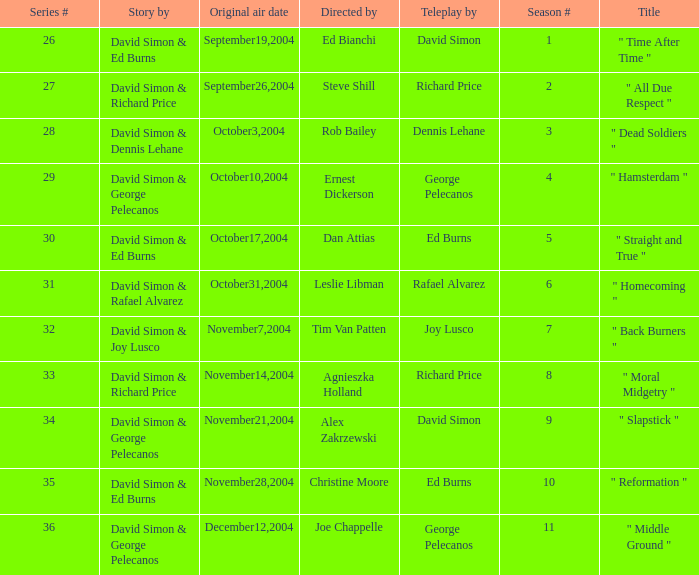Give me the full table as a dictionary. {'header': ['Series #', 'Story by', 'Original air date', 'Directed by', 'Teleplay by', 'Season #', 'Title'], 'rows': [['26', 'David Simon & Ed Burns', 'September19,2004', 'Ed Bianchi', 'David Simon', '1', '" Time After Time "'], ['27', 'David Simon & Richard Price', 'September26,2004', 'Steve Shill', 'Richard Price', '2', '" All Due Respect "'], ['28', 'David Simon & Dennis Lehane', 'October3,2004', 'Rob Bailey', 'Dennis Lehane', '3', '" Dead Soldiers "'], ['29', 'David Simon & George Pelecanos', 'October10,2004', 'Ernest Dickerson', 'George Pelecanos', '4', '" Hamsterdam "'], ['30', 'David Simon & Ed Burns', 'October17,2004', 'Dan Attias', 'Ed Burns', '5', '" Straight and True "'], ['31', 'David Simon & Rafael Alvarez', 'October31,2004', 'Leslie Libman', 'Rafael Alvarez', '6', '" Homecoming "'], ['32', 'David Simon & Joy Lusco', 'November7,2004', 'Tim Van Patten', 'Joy Lusco', '7', '" Back Burners "'], ['33', 'David Simon & Richard Price', 'November14,2004', 'Agnieszka Holland', 'Richard Price', '8', '" Moral Midgetry "'], ['34', 'David Simon & George Pelecanos', 'November21,2004', 'Alex Zakrzewski', 'David Simon', '9', '" Slapstick "'], ['35', 'David Simon & Ed Burns', 'November28,2004', 'Christine Moore', 'Ed Burns', '10', '" Reformation "'], ['36', 'David Simon & George Pelecanos', 'December12,2004', 'Joe Chappelle', 'George Pelecanos', '11', '" Middle Ground "']]} Who is the teleplay by when the director is Rob Bailey? Dennis Lehane. 